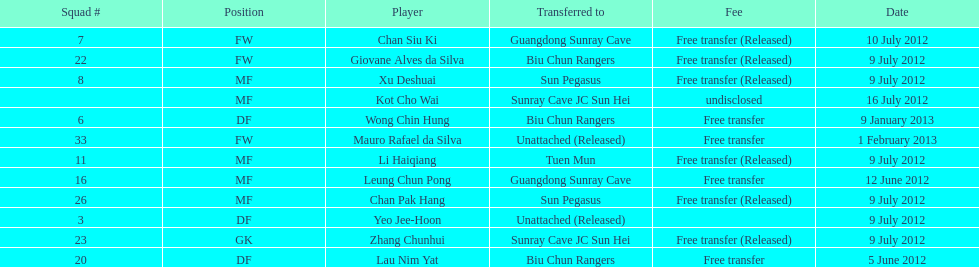How many total players were transferred to sun pegasus? 2. 